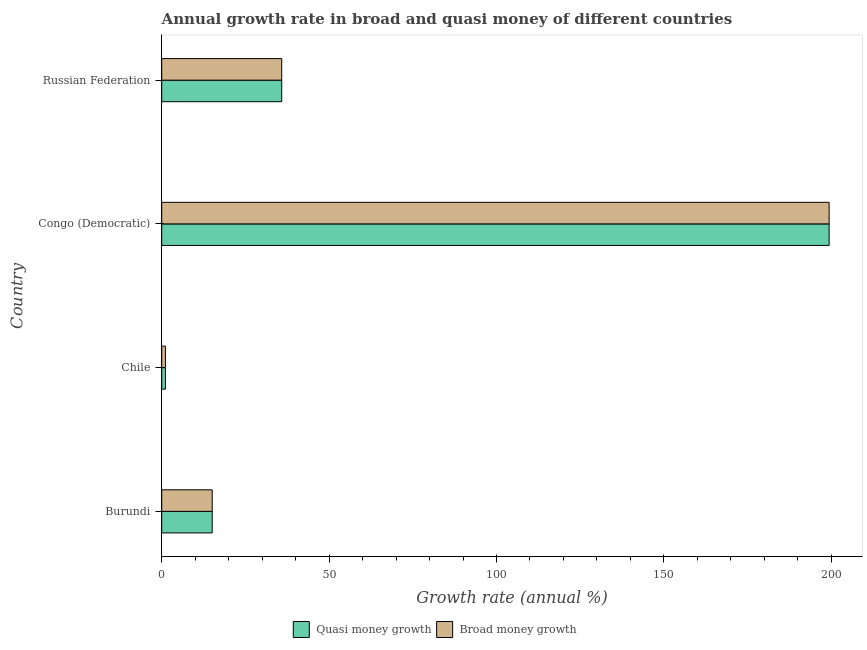How many different coloured bars are there?
Offer a very short reply. 2. Are the number of bars on each tick of the Y-axis equal?
Your response must be concise. Yes. How many bars are there on the 2nd tick from the top?
Provide a short and direct response. 2. How many bars are there on the 4th tick from the bottom?
Keep it short and to the point. 2. What is the label of the 2nd group of bars from the top?
Keep it short and to the point. Congo (Democratic). In how many cases, is the number of bars for a given country not equal to the number of legend labels?
Offer a very short reply. 0. What is the annual growth rate in broad money in Chile?
Provide a succinct answer. 1.11. Across all countries, what is the maximum annual growth rate in broad money?
Provide a short and direct response. 199.36. Across all countries, what is the minimum annual growth rate in quasi money?
Your answer should be very brief. 1.11. In which country was the annual growth rate in broad money maximum?
Ensure brevity in your answer.  Congo (Democratic). What is the total annual growth rate in broad money in the graph?
Provide a short and direct response. 251.4. What is the difference between the annual growth rate in quasi money in Chile and that in Congo (Democratic)?
Give a very brief answer. -198.25. What is the difference between the annual growth rate in broad money in Congo (Democratic) and the annual growth rate in quasi money in Chile?
Provide a succinct answer. 198.25. What is the average annual growth rate in broad money per country?
Your response must be concise. 62.85. What is the difference between the annual growth rate in broad money and annual growth rate in quasi money in Congo (Democratic)?
Provide a short and direct response. 0. What is the ratio of the annual growth rate in broad money in Burundi to that in Russian Federation?
Give a very brief answer. 0.42. Is the annual growth rate in broad money in Burundi less than that in Congo (Democratic)?
Keep it short and to the point. Yes. Is the difference between the annual growth rate in broad money in Burundi and Congo (Democratic) greater than the difference between the annual growth rate in quasi money in Burundi and Congo (Democratic)?
Offer a very short reply. No. What is the difference between the highest and the second highest annual growth rate in broad money?
Provide a short and direct response. 163.52. What is the difference between the highest and the lowest annual growth rate in quasi money?
Provide a succinct answer. 198.25. Is the sum of the annual growth rate in quasi money in Burundi and Russian Federation greater than the maximum annual growth rate in broad money across all countries?
Offer a terse response. No. What does the 2nd bar from the top in Congo (Democratic) represents?
Keep it short and to the point. Quasi money growth. What does the 1st bar from the bottom in Russian Federation represents?
Make the answer very short. Quasi money growth. How many countries are there in the graph?
Ensure brevity in your answer.  4. How are the legend labels stacked?
Make the answer very short. Horizontal. What is the title of the graph?
Offer a terse response. Annual growth rate in broad and quasi money of different countries. Does "Banks" appear as one of the legend labels in the graph?
Make the answer very short. No. What is the label or title of the X-axis?
Make the answer very short. Growth rate (annual %). What is the Growth rate (annual %) of Quasi money growth in Burundi?
Your answer should be very brief. 15.08. What is the Growth rate (annual %) of Broad money growth in Burundi?
Offer a very short reply. 15.08. What is the Growth rate (annual %) in Quasi money growth in Chile?
Your answer should be compact. 1.11. What is the Growth rate (annual %) of Broad money growth in Chile?
Your response must be concise. 1.11. What is the Growth rate (annual %) of Quasi money growth in Congo (Democratic)?
Offer a terse response. 199.36. What is the Growth rate (annual %) of Broad money growth in Congo (Democratic)?
Ensure brevity in your answer.  199.36. What is the Growth rate (annual %) of Quasi money growth in Russian Federation?
Provide a succinct answer. 35.85. What is the Growth rate (annual %) in Broad money growth in Russian Federation?
Make the answer very short. 35.85. Across all countries, what is the maximum Growth rate (annual %) of Quasi money growth?
Your answer should be compact. 199.36. Across all countries, what is the maximum Growth rate (annual %) of Broad money growth?
Offer a very short reply. 199.36. Across all countries, what is the minimum Growth rate (annual %) in Quasi money growth?
Offer a terse response. 1.11. Across all countries, what is the minimum Growth rate (annual %) in Broad money growth?
Your answer should be very brief. 1.11. What is the total Growth rate (annual %) of Quasi money growth in the graph?
Offer a terse response. 251.4. What is the total Growth rate (annual %) of Broad money growth in the graph?
Your response must be concise. 251.4. What is the difference between the Growth rate (annual %) of Quasi money growth in Burundi and that in Chile?
Offer a terse response. 13.97. What is the difference between the Growth rate (annual %) of Broad money growth in Burundi and that in Chile?
Your answer should be very brief. 13.97. What is the difference between the Growth rate (annual %) in Quasi money growth in Burundi and that in Congo (Democratic)?
Make the answer very short. -184.28. What is the difference between the Growth rate (annual %) in Broad money growth in Burundi and that in Congo (Democratic)?
Keep it short and to the point. -184.28. What is the difference between the Growth rate (annual %) in Quasi money growth in Burundi and that in Russian Federation?
Offer a very short reply. -20.76. What is the difference between the Growth rate (annual %) of Broad money growth in Burundi and that in Russian Federation?
Offer a very short reply. -20.76. What is the difference between the Growth rate (annual %) in Quasi money growth in Chile and that in Congo (Democratic)?
Make the answer very short. -198.25. What is the difference between the Growth rate (annual %) of Broad money growth in Chile and that in Congo (Democratic)?
Your answer should be compact. -198.25. What is the difference between the Growth rate (annual %) of Quasi money growth in Chile and that in Russian Federation?
Offer a terse response. -34.73. What is the difference between the Growth rate (annual %) of Broad money growth in Chile and that in Russian Federation?
Provide a succinct answer. -34.73. What is the difference between the Growth rate (annual %) of Quasi money growth in Congo (Democratic) and that in Russian Federation?
Your answer should be compact. 163.52. What is the difference between the Growth rate (annual %) in Broad money growth in Congo (Democratic) and that in Russian Federation?
Provide a succinct answer. 163.52. What is the difference between the Growth rate (annual %) of Quasi money growth in Burundi and the Growth rate (annual %) of Broad money growth in Chile?
Keep it short and to the point. 13.97. What is the difference between the Growth rate (annual %) in Quasi money growth in Burundi and the Growth rate (annual %) in Broad money growth in Congo (Democratic)?
Ensure brevity in your answer.  -184.28. What is the difference between the Growth rate (annual %) in Quasi money growth in Burundi and the Growth rate (annual %) in Broad money growth in Russian Federation?
Provide a succinct answer. -20.76. What is the difference between the Growth rate (annual %) in Quasi money growth in Chile and the Growth rate (annual %) in Broad money growth in Congo (Democratic)?
Offer a terse response. -198.25. What is the difference between the Growth rate (annual %) of Quasi money growth in Chile and the Growth rate (annual %) of Broad money growth in Russian Federation?
Provide a short and direct response. -34.73. What is the difference between the Growth rate (annual %) in Quasi money growth in Congo (Democratic) and the Growth rate (annual %) in Broad money growth in Russian Federation?
Provide a short and direct response. 163.52. What is the average Growth rate (annual %) of Quasi money growth per country?
Offer a very short reply. 62.85. What is the average Growth rate (annual %) in Broad money growth per country?
Offer a terse response. 62.85. What is the difference between the Growth rate (annual %) in Quasi money growth and Growth rate (annual %) in Broad money growth in Burundi?
Give a very brief answer. 0. What is the ratio of the Growth rate (annual %) in Quasi money growth in Burundi to that in Chile?
Make the answer very short. 13.55. What is the ratio of the Growth rate (annual %) of Broad money growth in Burundi to that in Chile?
Your answer should be very brief. 13.55. What is the ratio of the Growth rate (annual %) in Quasi money growth in Burundi to that in Congo (Democratic)?
Make the answer very short. 0.08. What is the ratio of the Growth rate (annual %) in Broad money growth in Burundi to that in Congo (Democratic)?
Give a very brief answer. 0.08. What is the ratio of the Growth rate (annual %) of Quasi money growth in Burundi to that in Russian Federation?
Provide a short and direct response. 0.42. What is the ratio of the Growth rate (annual %) of Broad money growth in Burundi to that in Russian Federation?
Provide a succinct answer. 0.42. What is the ratio of the Growth rate (annual %) in Quasi money growth in Chile to that in Congo (Democratic)?
Your response must be concise. 0.01. What is the ratio of the Growth rate (annual %) in Broad money growth in Chile to that in Congo (Democratic)?
Give a very brief answer. 0.01. What is the ratio of the Growth rate (annual %) in Quasi money growth in Chile to that in Russian Federation?
Your answer should be very brief. 0.03. What is the ratio of the Growth rate (annual %) in Broad money growth in Chile to that in Russian Federation?
Your answer should be very brief. 0.03. What is the ratio of the Growth rate (annual %) in Quasi money growth in Congo (Democratic) to that in Russian Federation?
Make the answer very short. 5.56. What is the ratio of the Growth rate (annual %) in Broad money growth in Congo (Democratic) to that in Russian Federation?
Your answer should be compact. 5.56. What is the difference between the highest and the second highest Growth rate (annual %) of Quasi money growth?
Offer a very short reply. 163.52. What is the difference between the highest and the second highest Growth rate (annual %) in Broad money growth?
Your answer should be compact. 163.52. What is the difference between the highest and the lowest Growth rate (annual %) of Quasi money growth?
Your answer should be compact. 198.25. What is the difference between the highest and the lowest Growth rate (annual %) in Broad money growth?
Ensure brevity in your answer.  198.25. 